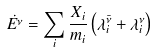Convert formula to latex. <formula><loc_0><loc_0><loc_500><loc_500>\dot { E ^ { \nu } } = \sum _ { i } { \frac { X _ { i } } { m _ { i } } \left ( \lambda ^ { \bar { \nu } } _ { i } + \lambda ^ { \nu } _ { i } \right ) }</formula> 